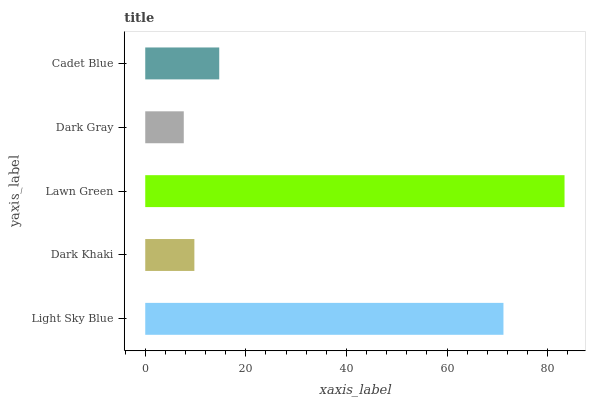Is Dark Gray the minimum?
Answer yes or no. Yes. Is Lawn Green the maximum?
Answer yes or no. Yes. Is Dark Khaki the minimum?
Answer yes or no. No. Is Dark Khaki the maximum?
Answer yes or no. No. Is Light Sky Blue greater than Dark Khaki?
Answer yes or no. Yes. Is Dark Khaki less than Light Sky Blue?
Answer yes or no. Yes. Is Dark Khaki greater than Light Sky Blue?
Answer yes or no. No. Is Light Sky Blue less than Dark Khaki?
Answer yes or no. No. Is Cadet Blue the high median?
Answer yes or no. Yes. Is Cadet Blue the low median?
Answer yes or no. Yes. Is Light Sky Blue the high median?
Answer yes or no. No. Is Lawn Green the low median?
Answer yes or no. No. 